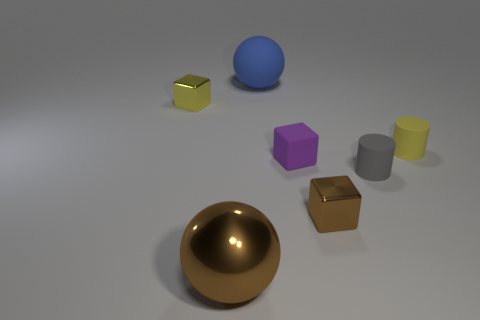Besides the sphere and cube, are there other geometric shapes visible? Yes, apart from the sphere and cube, there's a cylinder and an object that looks like a hexagonal prism. 